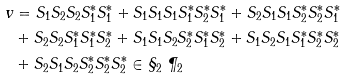<formula> <loc_0><loc_0><loc_500><loc_500>v & = S _ { 1 } S _ { 2 } S _ { 2 } S _ { 1 } ^ { * } S _ { 1 } ^ { * } + S _ { 1 } S _ { 1 } S _ { 1 } S _ { 1 } ^ { * } S _ { 2 } ^ { * } S _ { 1 } ^ { * } + S _ { 2 } S _ { 1 } S _ { 1 } S _ { 2 } ^ { * } S _ { 2 } ^ { * } S _ { 1 } ^ { * } \\ & + S _ { 2 } S _ { 2 } S _ { 1 } ^ { * } S _ { 1 } ^ { * } S _ { 2 } ^ { * } + S _ { 1 } S _ { 1 } S _ { 2 } S _ { 2 } ^ { * } S _ { 1 } ^ { * } S _ { 2 } ^ { * } + S _ { 1 } S _ { 2 } S _ { 1 } S _ { 1 } ^ { * } S _ { 2 } ^ { * } S _ { 2 } ^ { * } \\ & + S _ { 2 } S _ { 1 } S _ { 2 } S _ { 2 } ^ { * } S _ { 2 } ^ { * } S _ { 2 } ^ { * } \in \S _ { 2 } \ \P _ { 2 }</formula> 